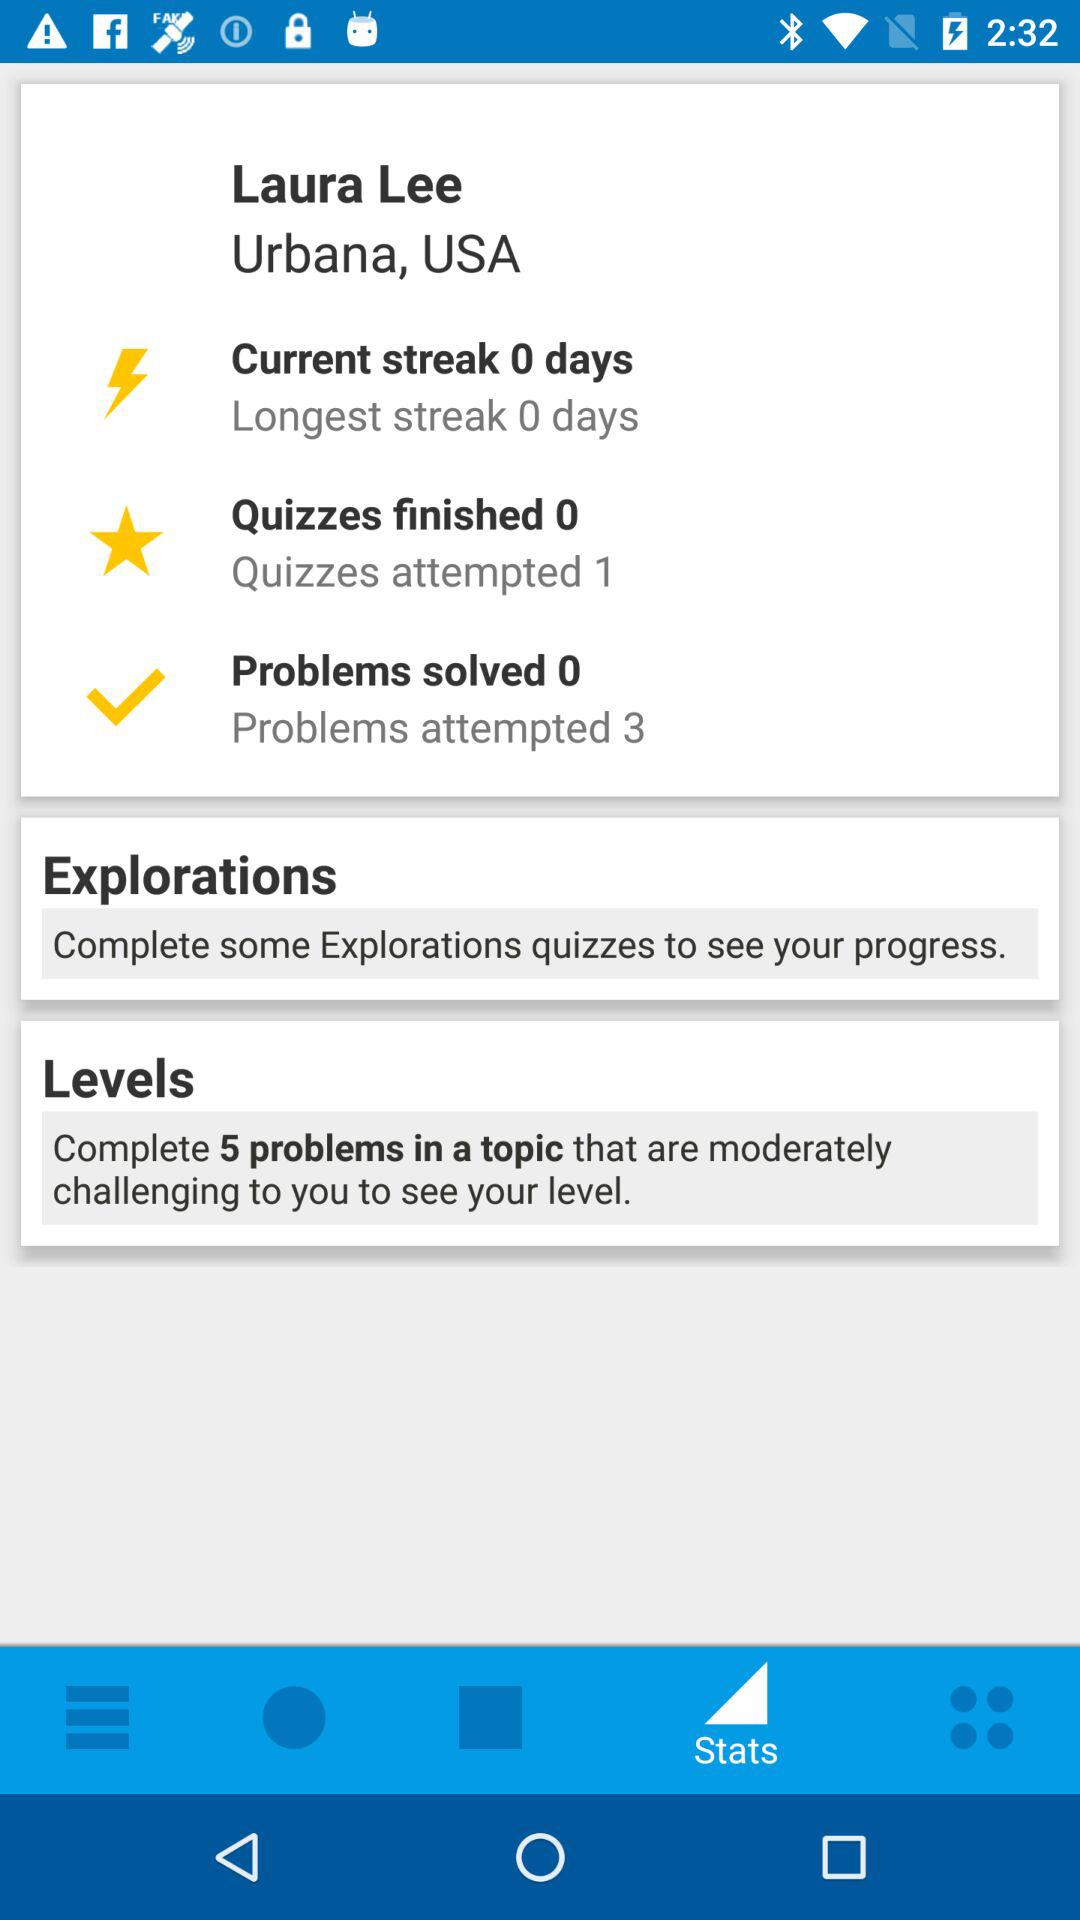How many more quizzes have been attempted than finished?
Answer the question using a single word or phrase. 1 